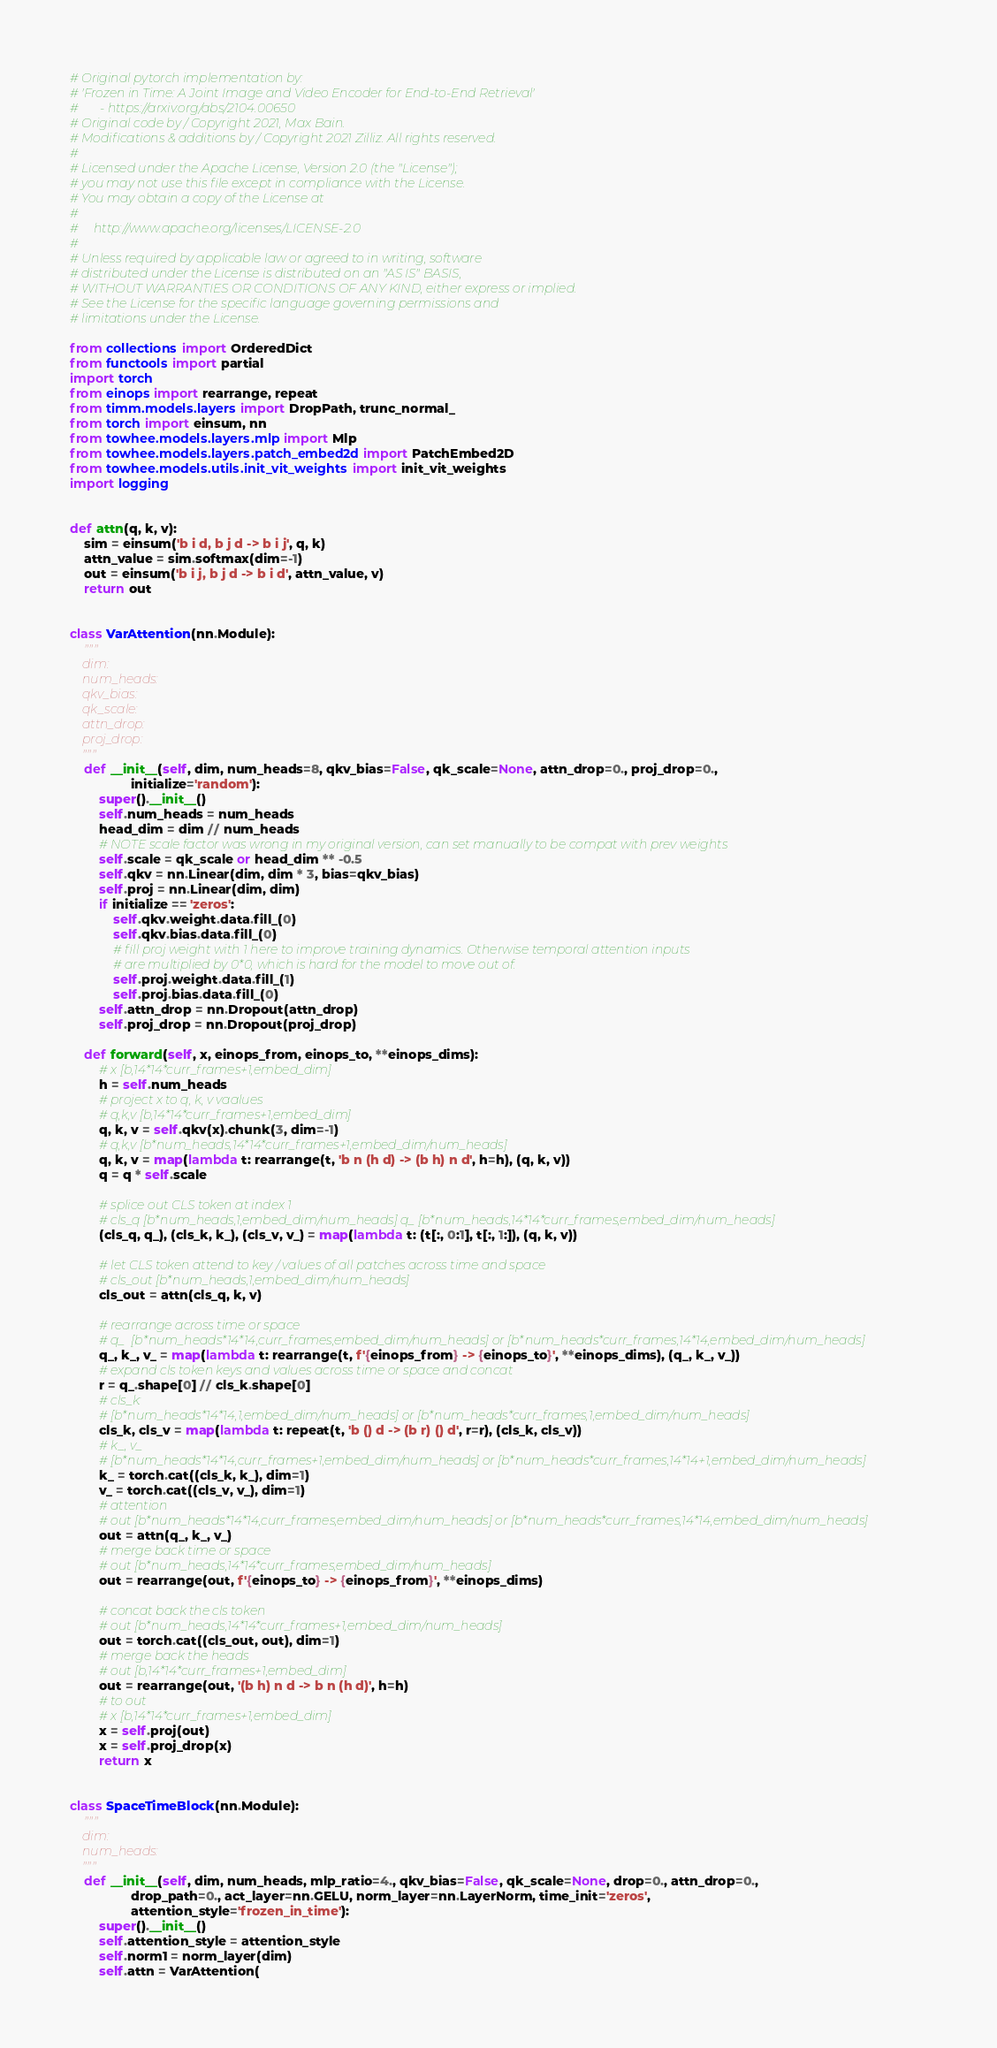<code> <loc_0><loc_0><loc_500><loc_500><_Python_># Original pytorch implementation by:
# 'Frozen in Time: A Joint Image and Video Encoder for End-to-End Retrieval'
#       - https://arxiv.org/abs/2104.00650
# Original code by / Copyright 2021, Max Bain.
# Modifications & additions by / Copyright 2021 Zilliz. All rights reserved.
#
# Licensed under the Apache License, Version 2.0 (the "License");
# you may not use this file except in compliance with the License.
# You may obtain a copy of the License at
#
#     http://www.apache.org/licenses/LICENSE-2.0
#
# Unless required by applicable law or agreed to in writing, software
# distributed under the License is distributed on an "AS IS" BASIS,
# WITHOUT WARRANTIES OR CONDITIONS OF ANY KIND, either express or implied.
# See the License for the specific language governing permissions and
# limitations under the License.

from collections import OrderedDict
from functools import partial
import torch
from einops import rearrange, repeat
from timm.models.layers import DropPath, trunc_normal_
from torch import einsum, nn
from towhee.models.layers.mlp import Mlp
from towhee.models.layers.patch_embed2d import PatchEmbed2D
from towhee.models.utils.init_vit_weights import init_vit_weights
import logging


def attn(q, k, v):
    sim = einsum('b i d, b j d -> b i j', q, k)
    attn_value = sim.softmax(dim=-1)
    out = einsum('b i j, b j d -> b i d', attn_value, v)
    return out


class VarAttention(nn.Module):
    """
    dim:
    num_heads:
    qkv_bias:
    qk_scale:
    attn_drop:
    proj_drop:
    """
    def __init__(self, dim, num_heads=8, qkv_bias=False, qk_scale=None, attn_drop=0., proj_drop=0.,
                 initialize='random'):
        super().__init__()
        self.num_heads = num_heads
        head_dim = dim // num_heads
        # NOTE scale factor was wrong in my original version, can set manually to be compat with prev weights
        self.scale = qk_scale or head_dim ** -0.5
        self.qkv = nn.Linear(dim, dim * 3, bias=qkv_bias)
        self.proj = nn.Linear(dim, dim)
        if initialize == 'zeros':
            self.qkv.weight.data.fill_(0)
            self.qkv.bias.data.fill_(0)
            # fill proj weight with 1 here to improve training dynamics. Otherwise temporal attention inputs
            # are multiplied by 0*0, which is hard for the model to move out of.
            self.proj.weight.data.fill_(1)
            self.proj.bias.data.fill_(0)
        self.attn_drop = nn.Dropout(attn_drop)
        self.proj_drop = nn.Dropout(proj_drop)

    def forward(self, x, einops_from, einops_to, **einops_dims):
        # x [b,14*14*curr_frames+1,embed_dim]
        h = self.num_heads
        # project x to q, k, v vaalues
        # q,k,v [b,14*14*curr_frames+1,embed_dim]
        q, k, v = self.qkv(x).chunk(3, dim=-1)
        # q,k,v [b*num_heads,14*14*curr_frames+1,embed_dim/num_heads]
        q, k, v = map(lambda t: rearrange(t, 'b n (h d) -> (b h) n d', h=h), (q, k, v))
        q = q * self.scale

        # splice out CLS token at index 1
        # cls_q [b*num_heads,1,embed_dim/num_heads] q_ [b*num_heads,14*14*curr_frames,embed_dim/num_heads]
        (cls_q, q_), (cls_k, k_), (cls_v, v_) = map(lambda t: (t[:, 0:1], t[:, 1:]), (q, k, v))

        # let CLS token attend to key / values of all patches across time and space
        # cls_out [b*num_heads,1,embed_dim/num_heads]
        cls_out = attn(cls_q, k, v)

        # rearrange across time or space
        # q_  [b*num_heads*14*14,curr_frames,embed_dim/num_heads] or [b*num_heads*curr_frames,14*14,embed_dim/num_heads]
        q_, k_, v_ = map(lambda t: rearrange(t, f'{einops_from} -> {einops_to}', **einops_dims), (q_, k_, v_))
        # expand cls token keys and values across time or space and concat
        r = q_.shape[0] // cls_k.shape[0]
        # cls_k:
        # [b*num_heads*14*14,1,embed_dim/num_heads] or [b*num_heads*curr_frames,1,embed_dim/num_heads]
        cls_k, cls_v = map(lambda t: repeat(t, 'b () d -> (b r) () d', r=r), (cls_k, cls_v))
        # k_, v_
        # [b*num_heads*14*14,curr_frames+1,embed_dim/num_heads] or [b*num_heads*curr_frames,14*14+1,embed_dim/num_heads]
        k_ = torch.cat((cls_k, k_), dim=1)
        v_ = torch.cat((cls_v, v_), dim=1)
        # attention
        # out [b*num_heads*14*14,curr_frames,embed_dim/num_heads] or [b*num_heads*curr_frames,14*14,embed_dim/num_heads]
        out = attn(q_, k_, v_)
        # merge back time or space
        # out [b*num_heads,14*14*curr_frames,embed_dim/num_heads]
        out = rearrange(out, f'{einops_to} -> {einops_from}', **einops_dims)

        # concat back the cls token
        # out [b*num_heads,14*14*curr_frames+1,embed_dim/num_heads]
        out = torch.cat((cls_out, out), dim=1)
        # merge back the heads
        # out [b,14*14*curr_frames+1,embed_dim]
        out = rearrange(out, '(b h) n d -> b n (h d)', h=h)
        # to out
        # x [b,14*14*curr_frames+1,embed_dim]
        x = self.proj(out)
        x = self.proj_drop(x)
        return x


class SpaceTimeBlock(nn.Module):
    """
    dim:
    num_heads:
    """
    def __init__(self, dim, num_heads, mlp_ratio=4., qkv_bias=False, qk_scale=None, drop=0., attn_drop=0.,
                 drop_path=0., act_layer=nn.GELU, norm_layer=nn.LayerNorm, time_init='zeros',
                 attention_style='frozen_in_time'):
        super().__init__()
        self.attention_style = attention_style
        self.norm1 = norm_layer(dim)
        self.attn = VarAttention(</code> 